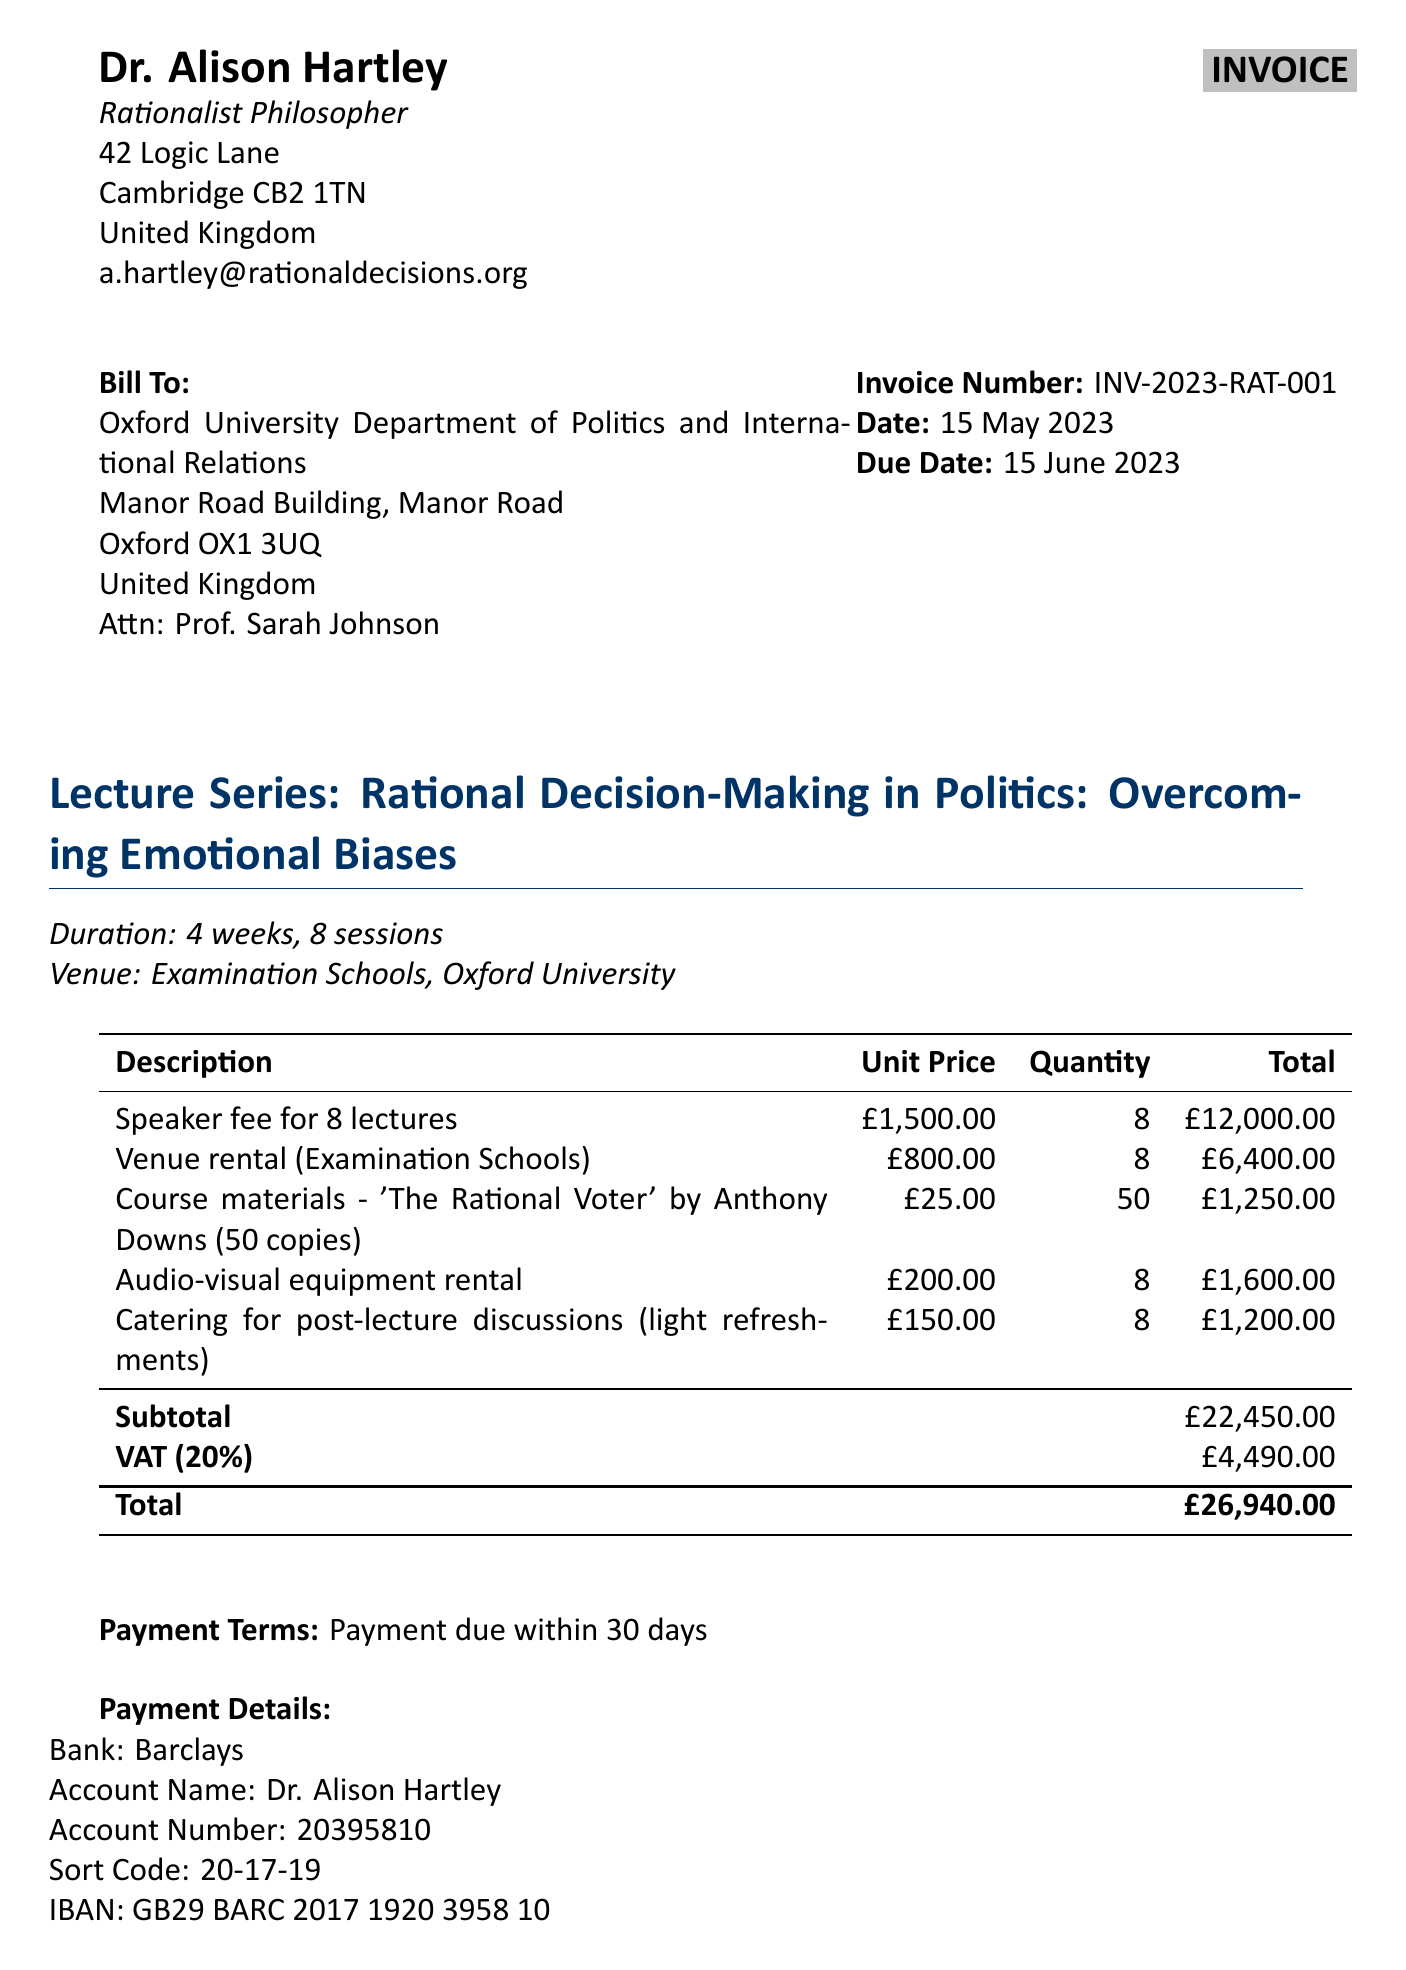What is the invoice number? The invoice number is a unique identifier for the invoice, which is listed in the document.
Answer: INV-2023-RAT-001 Who is the speaker for the lecture series? The speaker for the lecture series is mentioned in the 'from' section of the invoice.
Answer: Dr. Alison Hartley What is the total amount due? The total amount due is the final figure presented at the bottom of the invoice.
Answer: £26,940.00 What is the duration of the lecture series? The duration specifies how long the lecture series will last, as mentioned in the introduction section.
Answer: 4 weeks How many lectures will be delivered? The number of lectures is stated in the details of the lecture series.
Answer: 8 What is the tax rate applied to the invoice? The tax rate is given as a percentage in the financial summary of the invoice.
Answer: 20% What is the venue for the lectures? The venue where the lectures will be conducted is specified under the lecture series section.
Answer: Examination Schools, Oxford University When is the payment due? The payment due date is explicitly mentioned in the invoice.
Answer: 15 June 2023 What type of materials were included in the invoice? The invoice includes various items, and materials represent one category within those items.
Answer: Course materials - 'The Rational Voter' by Anthony Downs (50 copies) 